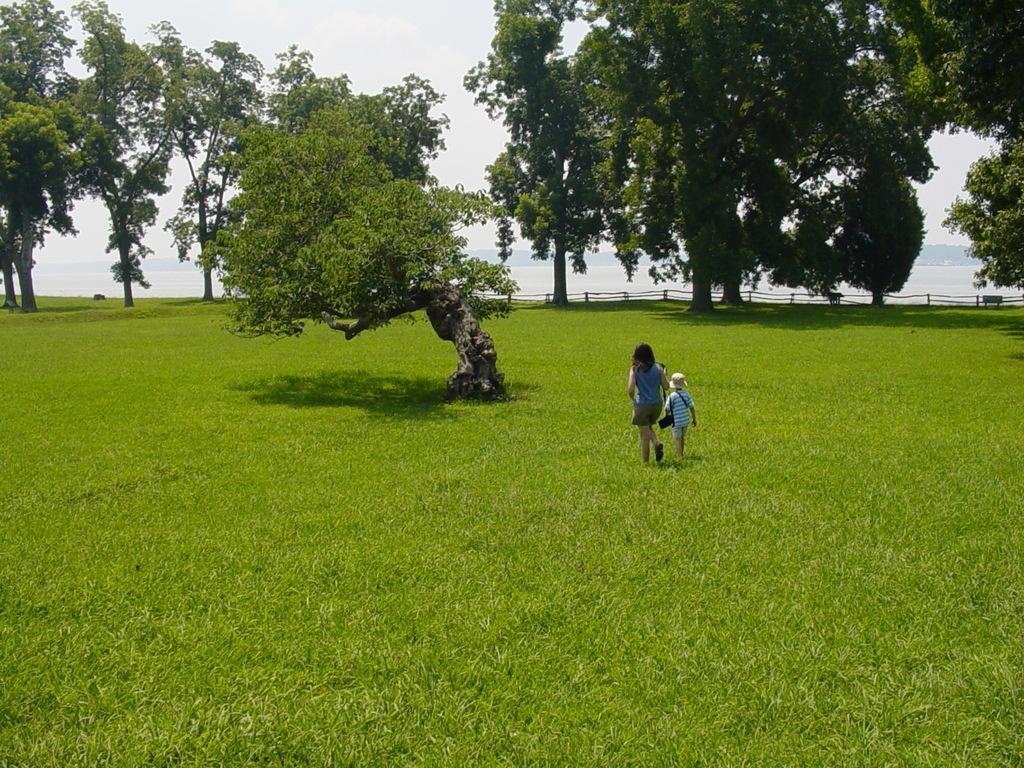Can you describe this image briefly? In this image there is one woman and one boy who are walking and at the bottom there is grass, and in the background there are some trees and fence. At the top there is sky. 